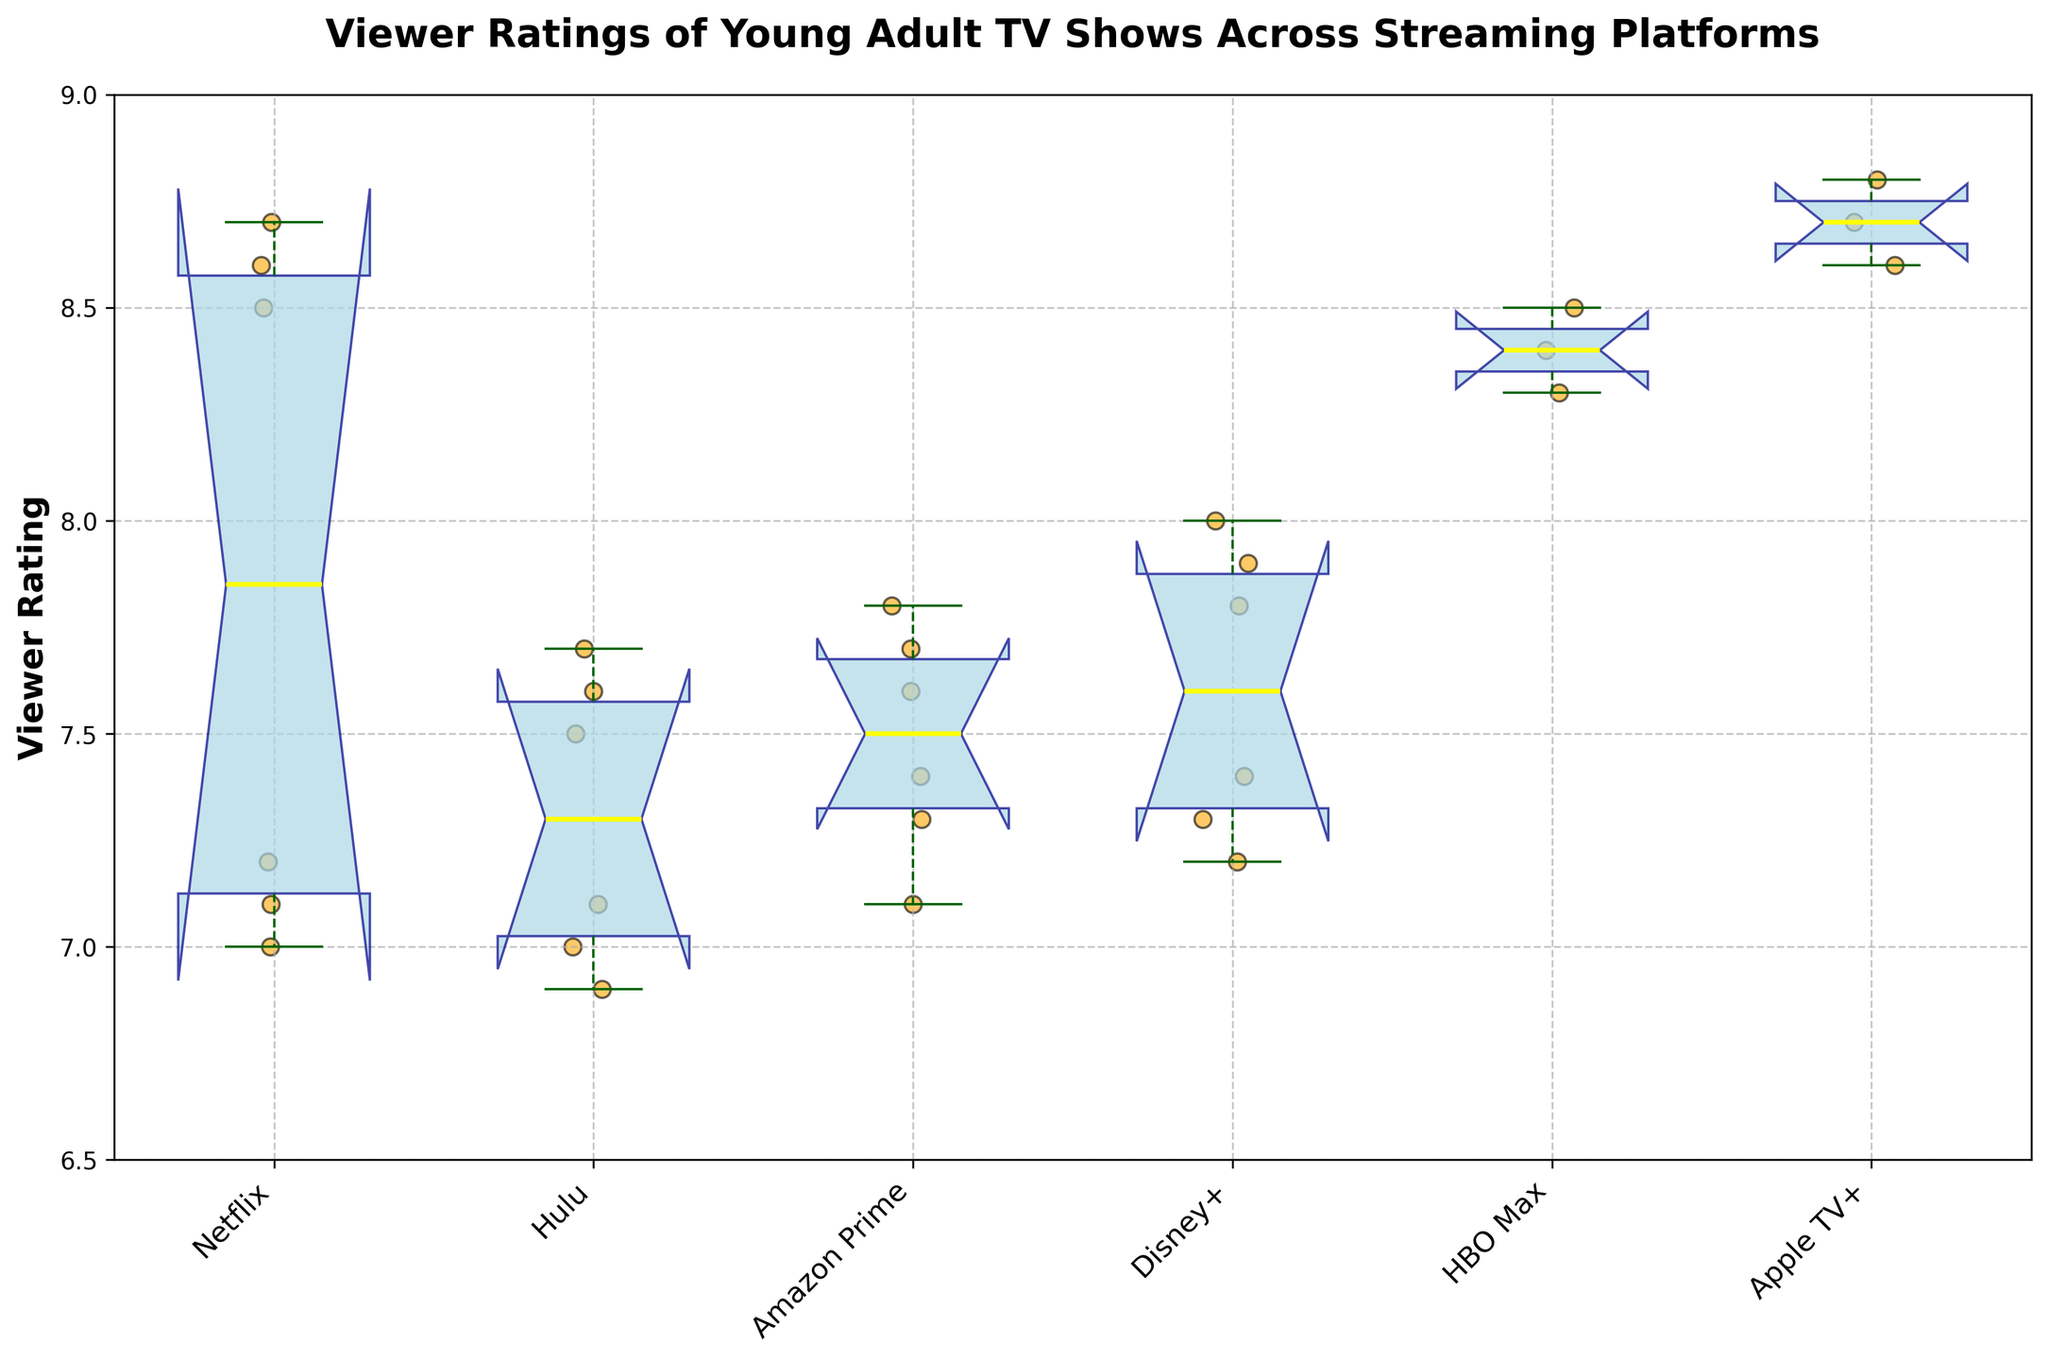What's the title of the plot? The title of the plot can be found at the top of the figure where it states what the plot represents.
Answer: "Viewer Ratings of Young Adult TV Shows Across Streaming Platforms" What are the streaming platforms presented in the plot? The streaming platforms can be identified by the labels on the x-axis. They are the unique categories shown.
Answer: Netflix, Hulu, Amazon Prime, Disney+, HBO Max, Apple TV+ Which platform has the highest median viewer rating? To find the highest median viewer rating, locate the yellow median line in each of the notched box plots and compare their vertical positions.
Answer: Apple TV+ What is the approximate range of viewer ratings for shows on Hulu? For Hulu, observe the bottom-most and top-most parts of the blue box (interquartile range) and the whiskers (minimum and maximum values) in the plot.
Answer: 6.9 to 7.7 Which platform has the largest spread in viewer ratings? To determine this, compare the distance between the smallest and largest values along the y-axis for each platform. Look at the ends of the whiskers and box lengths.
Answer: Netflix Are any of the notched intervals (medians) for different platforms overlapping? Check if the notched areas, which visualize the confidence intervals for the medians, intersect or overlap each other.
Answer: Yes, several notched intervals overlap How many data points are there for Disney+ shows? Count the individual orange scatter points plotted along the vertical line corresponding to Disney+.
Answer: 6 Which platform has the narrowest interquartile range (IQR) for viewer ratings? The IQR is represented by the height of the blue box. Compare the heights of the boxes for all platforms.
Answer: HBO Max Between Netflix and HBO Max, which has the higher variability in viewer ratings? Variability can be judged by the spread of the data points (whisker length and box height). Compare those features between Netflix and HBO Max.
Answer: Netflix 